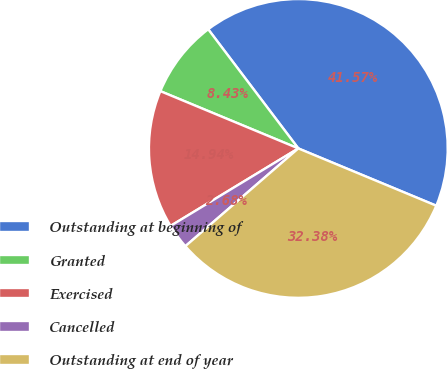Convert chart to OTSL. <chart><loc_0><loc_0><loc_500><loc_500><pie_chart><fcel>Outstanding at beginning of<fcel>Granted<fcel>Exercised<fcel>Cancelled<fcel>Outstanding at end of year<nl><fcel>41.57%<fcel>8.43%<fcel>14.94%<fcel>2.68%<fcel>32.38%<nl></chart> 